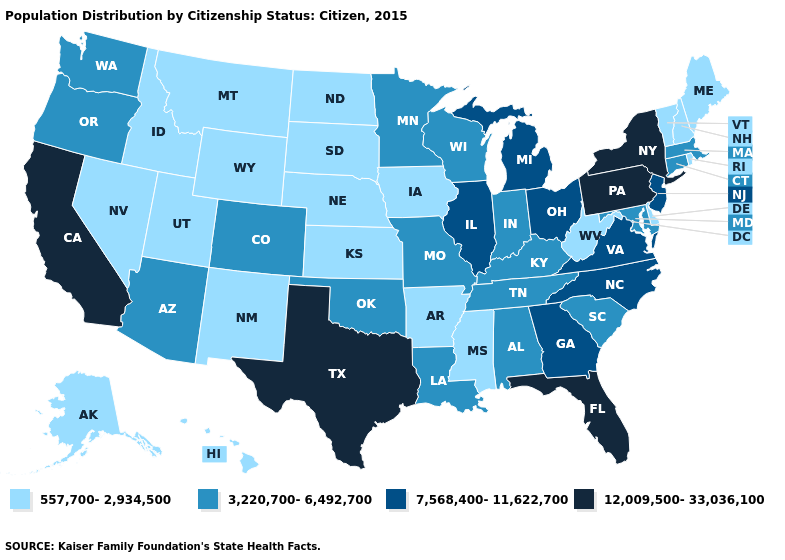Does the first symbol in the legend represent the smallest category?
Give a very brief answer. Yes. What is the value of Wyoming?
Be succinct. 557,700-2,934,500. What is the value of Virginia?
Quick response, please. 7,568,400-11,622,700. Does Michigan have the lowest value in the MidWest?
Write a very short answer. No. Name the states that have a value in the range 557,700-2,934,500?
Write a very short answer. Alaska, Arkansas, Delaware, Hawaii, Idaho, Iowa, Kansas, Maine, Mississippi, Montana, Nebraska, Nevada, New Hampshire, New Mexico, North Dakota, Rhode Island, South Dakota, Utah, Vermont, West Virginia, Wyoming. What is the lowest value in states that border Illinois?
Give a very brief answer. 557,700-2,934,500. Which states have the lowest value in the Northeast?
Keep it brief. Maine, New Hampshire, Rhode Island, Vermont. Does Michigan have the highest value in the MidWest?
Give a very brief answer. Yes. How many symbols are there in the legend?
Short answer required. 4. What is the value of Kansas?
Answer briefly. 557,700-2,934,500. What is the highest value in the USA?
Keep it brief. 12,009,500-33,036,100. Among the states that border North Carolina , which have the lowest value?
Be succinct. South Carolina, Tennessee. Name the states that have a value in the range 3,220,700-6,492,700?
Short answer required. Alabama, Arizona, Colorado, Connecticut, Indiana, Kentucky, Louisiana, Maryland, Massachusetts, Minnesota, Missouri, Oklahoma, Oregon, South Carolina, Tennessee, Washington, Wisconsin. What is the highest value in the USA?
Give a very brief answer. 12,009,500-33,036,100. How many symbols are there in the legend?
Be succinct. 4. 